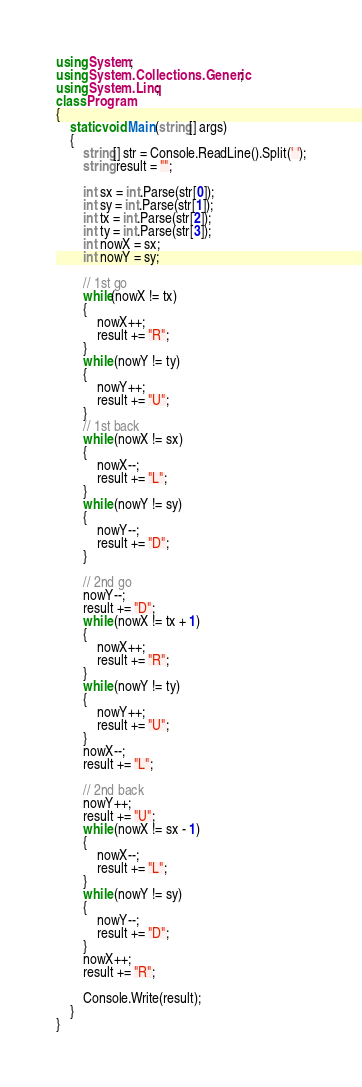Convert code to text. <code><loc_0><loc_0><loc_500><loc_500><_C#_>using System;
using System.Collections.Generic;
using System.Linq;
class Program
{
    static void Main(string[] args)
    {
        string[] str = Console.ReadLine().Split(' ');
        string result = "";

        int sx = int.Parse(str[0]);
        int sy = int.Parse(str[1]);
        int tx = int.Parse(str[2]);
        int ty = int.Parse(str[3]);
        int nowX = sx;
        int nowY = sy;

        // 1st go
        while(nowX != tx)
        {
            nowX++;
            result += "R";
        }
        while (nowY != ty)
        {
            nowY++;
            result += "U";
        }
        // 1st back
        while (nowX != sx)
        {
            nowX--;
            result += "L";
        }
        while (nowY != sy)
        {
            nowY--;
            result += "D";
        }

        // 2nd go
        nowY--;
        result += "D";
        while (nowX != tx + 1)
        {
            nowX++;
            result += "R";
        }
        while (nowY != ty)
        {
            nowY++;
            result += "U";
        }
        nowX--;
        result += "L";

        // 2nd back
        nowY++;
        result += "U";
        while (nowX != sx - 1)
        {
            nowX--;
            result += "L";
        }
        while (nowY != sy)
        {
            nowY--;
            result += "D";
        }
        nowX++;
        result += "R";

        Console.Write(result);
    }
}</code> 